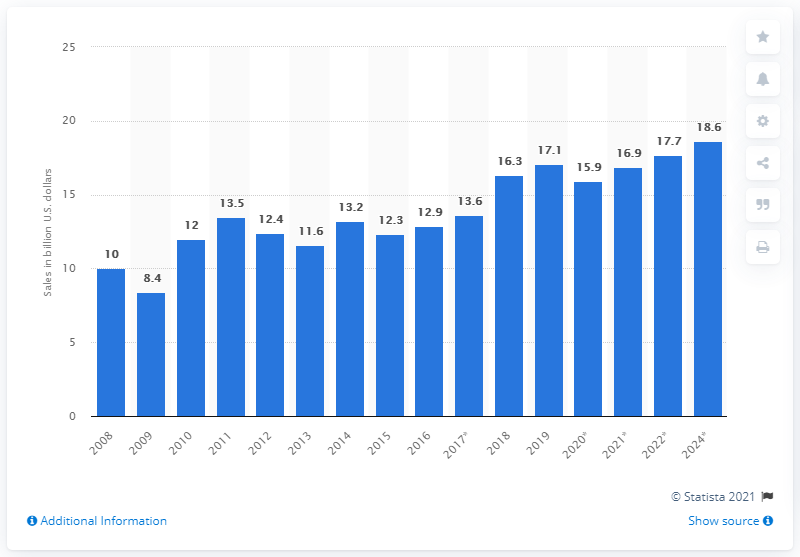Draw attention to some important aspects in this diagram. In 2021, the estimated total sales of power transistors were approximately 16.9 billion units. In 2019, the worldwide sales of power transistors totaled 17.1 billion units. 